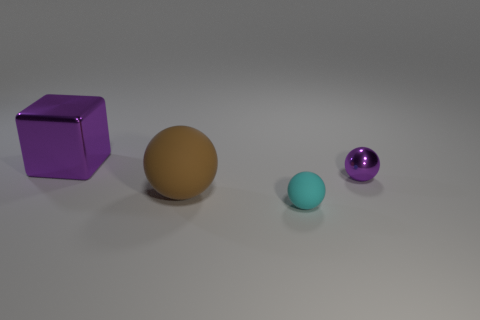Add 2 matte objects. How many objects exist? 6 Subtract all balls. How many objects are left? 1 Subtract 1 purple blocks. How many objects are left? 3 Subtract all purple metal things. Subtract all tiny blue cylinders. How many objects are left? 2 Add 3 large brown spheres. How many large brown spheres are left? 4 Add 3 blue matte objects. How many blue matte objects exist? 3 